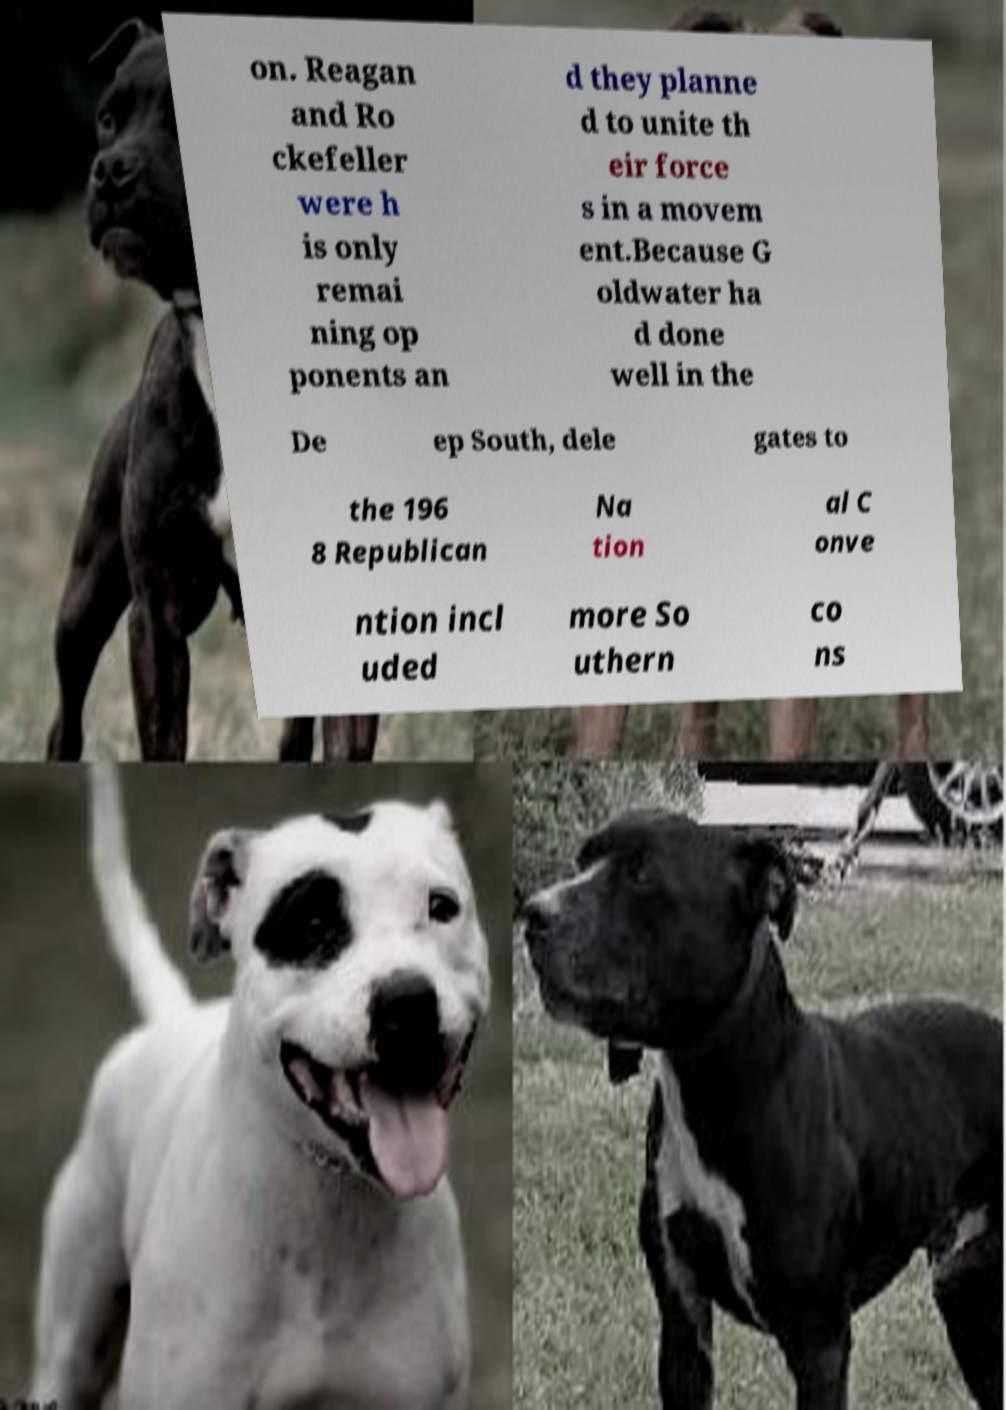What messages or text are displayed in this image? I need them in a readable, typed format. on. Reagan and Ro ckefeller were h is only remai ning op ponents an d they planne d to unite th eir force s in a movem ent.Because G oldwater ha d done well in the De ep South, dele gates to the 196 8 Republican Na tion al C onve ntion incl uded more So uthern co ns 